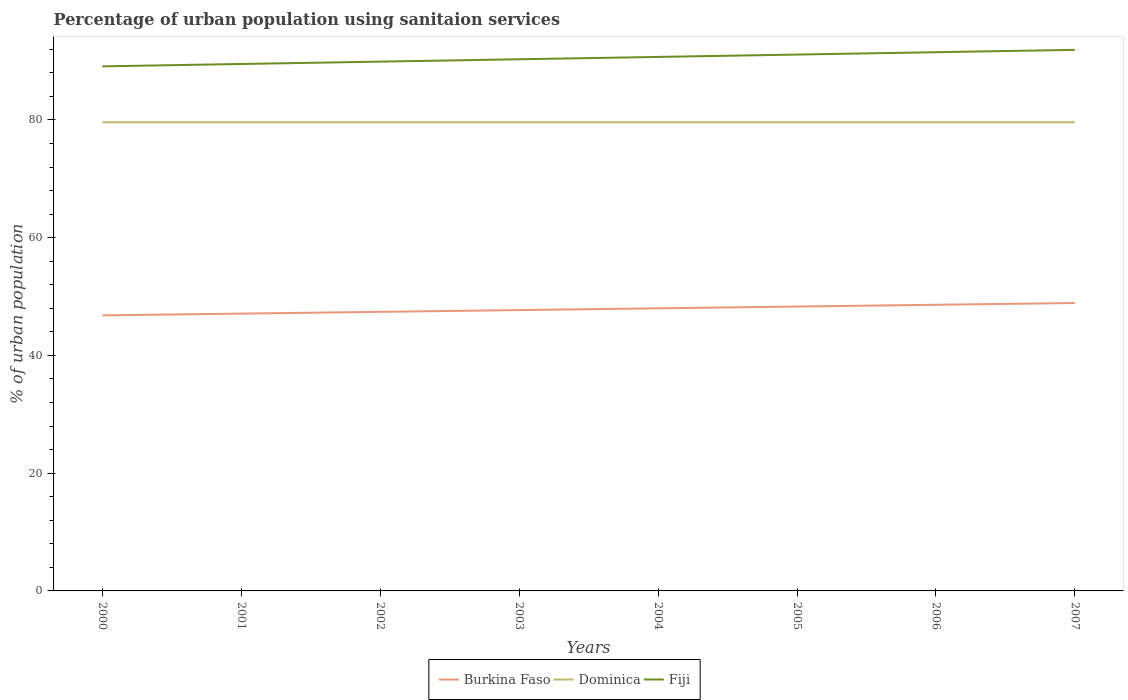Does the line corresponding to Dominica intersect with the line corresponding to Burkina Faso?
Your answer should be compact. No. Across all years, what is the maximum percentage of urban population using sanitaion services in Fiji?
Your response must be concise. 89.1. What is the difference between the highest and the lowest percentage of urban population using sanitaion services in Burkina Faso?
Make the answer very short. 4. How many lines are there?
Offer a terse response. 3. What is the difference between two consecutive major ticks on the Y-axis?
Provide a succinct answer. 20. Are the values on the major ticks of Y-axis written in scientific E-notation?
Your answer should be very brief. No. Where does the legend appear in the graph?
Your response must be concise. Bottom center. How many legend labels are there?
Your response must be concise. 3. How are the legend labels stacked?
Offer a terse response. Horizontal. What is the title of the graph?
Provide a short and direct response. Percentage of urban population using sanitaion services. Does "Andorra" appear as one of the legend labels in the graph?
Give a very brief answer. No. What is the label or title of the Y-axis?
Offer a very short reply. % of urban population. What is the % of urban population in Burkina Faso in 2000?
Make the answer very short. 46.8. What is the % of urban population in Dominica in 2000?
Offer a terse response. 79.6. What is the % of urban population in Fiji in 2000?
Offer a terse response. 89.1. What is the % of urban population of Burkina Faso in 2001?
Offer a terse response. 47.1. What is the % of urban population in Dominica in 2001?
Offer a very short reply. 79.6. What is the % of urban population in Fiji in 2001?
Give a very brief answer. 89.5. What is the % of urban population in Burkina Faso in 2002?
Keep it short and to the point. 47.4. What is the % of urban population in Dominica in 2002?
Offer a terse response. 79.6. What is the % of urban population in Fiji in 2002?
Ensure brevity in your answer.  89.9. What is the % of urban population of Burkina Faso in 2003?
Your answer should be compact. 47.7. What is the % of urban population of Dominica in 2003?
Give a very brief answer. 79.6. What is the % of urban population in Fiji in 2003?
Make the answer very short. 90.3. What is the % of urban population in Burkina Faso in 2004?
Provide a short and direct response. 48. What is the % of urban population in Dominica in 2004?
Give a very brief answer. 79.6. What is the % of urban population of Fiji in 2004?
Your answer should be very brief. 90.7. What is the % of urban population in Burkina Faso in 2005?
Ensure brevity in your answer.  48.3. What is the % of urban population in Dominica in 2005?
Your answer should be very brief. 79.6. What is the % of urban population of Fiji in 2005?
Your answer should be very brief. 91.1. What is the % of urban population of Burkina Faso in 2006?
Ensure brevity in your answer.  48.6. What is the % of urban population of Dominica in 2006?
Keep it short and to the point. 79.6. What is the % of urban population in Fiji in 2006?
Offer a terse response. 91.5. What is the % of urban population of Burkina Faso in 2007?
Provide a short and direct response. 48.9. What is the % of urban population in Dominica in 2007?
Offer a terse response. 79.6. What is the % of urban population in Fiji in 2007?
Give a very brief answer. 91.9. Across all years, what is the maximum % of urban population of Burkina Faso?
Offer a terse response. 48.9. Across all years, what is the maximum % of urban population in Dominica?
Ensure brevity in your answer.  79.6. Across all years, what is the maximum % of urban population of Fiji?
Your response must be concise. 91.9. Across all years, what is the minimum % of urban population in Burkina Faso?
Offer a terse response. 46.8. Across all years, what is the minimum % of urban population of Dominica?
Give a very brief answer. 79.6. Across all years, what is the minimum % of urban population in Fiji?
Your response must be concise. 89.1. What is the total % of urban population of Burkina Faso in the graph?
Give a very brief answer. 382.8. What is the total % of urban population of Dominica in the graph?
Ensure brevity in your answer.  636.8. What is the total % of urban population of Fiji in the graph?
Keep it short and to the point. 724. What is the difference between the % of urban population of Dominica in 2000 and that in 2002?
Provide a short and direct response. 0. What is the difference between the % of urban population in Fiji in 2000 and that in 2002?
Your answer should be compact. -0.8. What is the difference between the % of urban population in Fiji in 2000 and that in 2003?
Provide a succinct answer. -1.2. What is the difference between the % of urban population in Burkina Faso in 2000 and that in 2004?
Your answer should be very brief. -1.2. What is the difference between the % of urban population of Dominica in 2000 and that in 2004?
Make the answer very short. 0. What is the difference between the % of urban population of Fiji in 2000 and that in 2004?
Provide a succinct answer. -1.6. What is the difference between the % of urban population of Burkina Faso in 2000 and that in 2005?
Provide a succinct answer. -1.5. What is the difference between the % of urban population of Dominica in 2000 and that in 2005?
Keep it short and to the point. 0. What is the difference between the % of urban population of Fiji in 2000 and that in 2005?
Your response must be concise. -2. What is the difference between the % of urban population of Burkina Faso in 2000 and that in 2006?
Offer a terse response. -1.8. What is the difference between the % of urban population of Fiji in 2000 and that in 2007?
Make the answer very short. -2.8. What is the difference between the % of urban population in Dominica in 2001 and that in 2002?
Your response must be concise. 0. What is the difference between the % of urban population of Burkina Faso in 2001 and that in 2004?
Make the answer very short. -0.9. What is the difference between the % of urban population in Dominica in 2001 and that in 2004?
Give a very brief answer. 0. What is the difference between the % of urban population in Fiji in 2001 and that in 2004?
Give a very brief answer. -1.2. What is the difference between the % of urban population of Dominica in 2001 and that in 2005?
Offer a terse response. 0. What is the difference between the % of urban population of Burkina Faso in 2001 and that in 2006?
Offer a very short reply. -1.5. What is the difference between the % of urban population of Dominica in 2001 and that in 2006?
Your response must be concise. 0. What is the difference between the % of urban population of Burkina Faso in 2001 and that in 2007?
Provide a short and direct response. -1.8. What is the difference between the % of urban population in Burkina Faso in 2002 and that in 2003?
Offer a terse response. -0.3. What is the difference between the % of urban population of Dominica in 2002 and that in 2003?
Keep it short and to the point. 0. What is the difference between the % of urban population of Burkina Faso in 2002 and that in 2004?
Offer a terse response. -0.6. What is the difference between the % of urban population in Dominica in 2002 and that in 2005?
Give a very brief answer. 0. What is the difference between the % of urban population in Fiji in 2002 and that in 2005?
Your answer should be very brief. -1.2. What is the difference between the % of urban population of Fiji in 2002 and that in 2006?
Give a very brief answer. -1.6. What is the difference between the % of urban population in Dominica in 2002 and that in 2007?
Your response must be concise. 0. What is the difference between the % of urban population in Fiji in 2002 and that in 2007?
Offer a very short reply. -2. What is the difference between the % of urban population of Burkina Faso in 2003 and that in 2004?
Ensure brevity in your answer.  -0.3. What is the difference between the % of urban population of Burkina Faso in 2003 and that in 2005?
Give a very brief answer. -0.6. What is the difference between the % of urban population in Dominica in 2003 and that in 2005?
Keep it short and to the point. 0. What is the difference between the % of urban population in Fiji in 2003 and that in 2005?
Offer a terse response. -0.8. What is the difference between the % of urban population of Fiji in 2003 and that in 2006?
Your response must be concise. -1.2. What is the difference between the % of urban population of Burkina Faso in 2003 and that in 2007?
Offer a terse response. -1.2. What is the difference between the % of urban population of Fiji in 2003 and that in 2007?
Your response must be concise. -1.6. What is the difference between the % of urban population of Dominica in 2004 and that in 2005?
Keep it short and to the point. 0. What is the difference between the % of urban population in Dominica in 2004 and that in 2006?
Keep it short and to the point. 0. What is the difference between the % of urban population in Fiji in 2004 and that in 2006?
Make the answer very short. -0.8. What is the difference between the % of urban population in Burkina Faso in 2004 and that in 2007?
Provide a short and direct response. -0.9. What is the difference between the % of urban population of Dominica in 2004 and that in 2007?
Ensure brevity in your answer.  0. What is the difference between the % of urban population in Fiji in 2004 and that in 2007?
Offer a terse response. -1.2. What is the difference between the % of urban population in Dominica in 2005 and that in 2007?
Give a very brief answer. 0. What is the difference between the % of urban population in Burkina Faso in 2006 and that in 2007?
Your answer should be very brief. -0.3. What is the difference between the % of urban population in Dominica in 2006 and that in 2007?
Your answer should be compact. 0. What is the difference between the % of urban population of Burkina Faso in 2000 and the % of urban population of Dominica in 2001?
Keep it short and to the point. -32.8. What is the difference between the % of urban population of Burkina Faso in 2000 and the % of urban population of Fiji in 2001?
Your response must be concise. -42.7. What is the difference between the % of urban population of Burkina Faso in 2000 and the % of urban population of Dominica in 2002?
Provide a short and direct response. -32.8. What is the difference between the % of urban population in Burkina Faso in 2000 and the % of urban population in Fiji in 2002?
Your answer should be compact. -43.1. What is the difference between the % of urban population of Dominica in 2000 and the % of urban population of Fiji in 2002?
Offer a terse response. -10.3. What is the difference between the % of urban population in Burkina Faso in 2000 and the % of urban population in Dominica in 2003?
Make the answer very short. -32.8. What is the difference between the % of urban population in Burkina Faso in 2000 and the % of urban population in Fiji in 2003?
Your answer should be compact. -43.5. What is the difference between the % of urban population of Burkina Faso in 2000 and the % of urban population of Dominica in 2004?
Offer a terse response. -32.8. What is the difference between the % of urban population of Burkina Faso in 2000 and the % of urban population of Fiji in 2004?
Your response must be concise. -43.9. What is the difference between the % of urban population in Dominica in 2000 and the % of urban population in Fiji in 2004?
Provide a short and direct response. -11.1. What is the difference between the % of urban population in Burkina Faso in 2000 and the % of urban population in Dominica in 2005?
Make the answer very short. -32.8. What is the difference between the % of urban population of Burkina Faso in 2000 and the % of urban population of Fiji in 2005?
Your answer should be compact. -44.3. What is the difference between the % of urban population in Burkina Faso in 2000 and the % of urban population in Dominica in 2006?
Give a very brief answer. -32.8. What is the difference between the % of urban population in Burkina Faso in 2000 and the % of urban population in Fiji in 2006?
Keep it short and to the point. -44.7. What is the difference between the % of urban population of Burkina Faso in 2000 and the % of urban population of Dominica in 2007?
Make the answer very short. -32.8. What is the difference between the % of urban population of Burkina Faso in 2000 and the % of urban population of Fiji in 2007?
Your response must be concise. -45.1. What is the difference between the % of urban population in Burkina Faso in 2001 and the % of urban population in Dominica in 2002?
Your answer should be compact. -32.5. What is the difference between the % of urban population of Burkina Faso in 2001 and the % of urban population of Fiji in 2002?
Your answer should be very brief. -42.8. What is the difference between the % of urban population in Dominica in 2001 and the % of urban population in Fiji in 2002?
Your response must be concise. -10.3. What is the difference between the % of urban population in Burkina Faso in 2001 and the % of urban population in Dominica in 2003?
Keep it short and to the point. -32.5. What is the difference between the % of urban population of Burkina Faso in 2001 and the % of urban population of Fiji in 2003?
Your response must be concise. -43.2. What is the difference between the % of urban population of Dominica in 2001 and the % of urban population of Fiji in 2003?
Provide a short and direct response. -10.7. What is the difference between the % of urban population of Burkina Faso in 2001 and the % of urban population of Dominica in 2004?
Your answer should be compact. -32.5. What is the difference between the % of urban population in Burkina Faso in 2001 and the % of urban population in Fiji in 2004?
Provide a succinct answer. -43.6. What is the difference between the % of urban population in Dominica in 2001 and the % of urban population in Fiji in 2004?
Your answer should be compact. -11.1. What is the difference between the % of urban population in Burkina Faso in 2001 and the % of urban population in Dominica in 2005?
Your response must be concise. -32.5. What is the difference between the % of urban population of Burkina Faso in 2001 and the % of urban population of Fiji in 2005?
Offer a very short reply. -44. What is the difference between the % of urban population of Dominica in 2001 and the % of urban population of Fiji in 2005?
Your answer should be compact. -11.5. What is the difference between the % of urban population in Burkina Faso in 2001 and the % of urban population in Dominica in 2006?
Provide a short and direct response. -32.5. What is the difference between the % of urban population of Burkina Faso in 2001 and the % of urban population of Fiji in 2006?
Ensure brevity in your answer.  -44.4. What is the difference between the % of urban population in Burkina Faso in 2001 and the % of urban population in Dominica in 2007?
Your answer should be compact. -32.5. What is the difference between the % of urban population of Burkina Faso in 2001 and the % of urban population of Fiji in 2007?
Ensure brevity in your answer.  -44.8. What is the difference between the % of urban population in Dominica in 2001 and the % of urban population in Fiji in 2007?
Your response must be concise. -12.3. What is the difference between the % of urban population in Burkina Faso in 2002 and the % of urban population in Dominica in 2003?
Offer a terse response. -32.2. What is the difference between the % of urban population of Burkina Faso in 2002 and the % of urban population of Fiji in 2003?
Your answer should be very brief. -42.9. What is the difference between the % of urban population in Dominica in 2002 and the % of urban population in Fiji in 2003?
Provide a short and direct response. -10.7. What is the difference between the % of urban population of Burkina Faso in 2002 and the % of urban population of Dominica in 2004?
Your response must be concise. -32.2. What is the difference between the % of urban population of Burkina Faso in 2002 and the % of urban population of Fiji in 2004?
Offer a very short reply. -43.3. What is the difference between the % of urban population in Dominica in 2002 and the % of urban population in Fiji in 2004?
Provide a short and direct response. -11.1. What is the difference between the % of urban population in Burkina Faso in 2002 and the % of urban population in Dominica in 2005?
Your response must be concise. -32.2. What is the difference between the % of urban population in Burkina Faso in 2002 and the % of urban population in Fiji in 2005?
Make the answer very short. -43.7. What is the difference between the % of urban population of Dominica in 2002 and the % of urban population of Fiji in 2005?
Your answer should be compact. -11.5. What is the difference between the % of urban population of Burkina Faso in 2002 and the % of urban population of Dominica in 2006?
Your answer should be compact. -32.2. What is the difference between the % of urban population of Burkina Faso in 2002 and the % of urban population of Fiji in 2006?
Ensure brevity in your answer.  -44.1. What is the difference between the % of urban population of Dominica in 2002 and the % of urban population of Fiji in 2006?
Offer a terse response. -11.9. What is the difference between the % of urban population of Burkina Faso in 2002 and the % of urban population of Dominica in 2007?
Your response must be concise. -32.2. What is the difference between the % of urban population of Burkina Faso in 2002 and the % of urban population of Fiji in 2007?
Your answer should be very brief. -44.5. What is the difference between the % of urban population of Dominica in 2002 and the % of urban population of Fiji in 2007?
Give a very brief answer. -12.3. What is the difference between the % of urban population in Burkina Faso in 2003 and the % of urban population in Dominica in 2004?
Your answer should be compact. -31.9. What is the difference between the % of urban population of Burkina Faso in 2003 and the % of urban population of Fiji in 2004?
Provide a succinct answer. -43. What is the difference between the % of urban population in Burkina Faso in 2003 and the % of urban population in Dominica in 2005?
Provide a succinct answer. -31.9. What is the difference between the % of urban population of Burkina Faso in 2003 and the % of urban population of Fiji in 2005?
Offer a terse response. -43.4. What is the difference between the % of urban population of Dominica in 2003 and the % of urban population of Fiji in 2005?
Provide a short and direct response. -11.5. What is the difference between the % of urban population in Burkina Faso in 2003 and the % of urban population in Dominica in 2006?
Your answer should be very brief. -31.9. What is the difference between the % of urban population in Burkina Faso in 2003 and the % of urban population in Fiji in 2006?
Keep it short and to the point. -43.8. What is the difference between the % of urban population in Dominica in 2003 and the % of urban population in Fiji in 2006?
Your response must be concise. -11.9. What is the difference between the % of urban population of Burkina Faso in 2003 and the % of urban population of Dominica in 2007?
Provide a succinct answer. -31.9. What is the difference between the % of urban population in Burkina Faso in 2003 and the % of urban population in Fiji in 2007?
Make the answer very short. -44.2. What is the difference between the % of urban population of Burkina Faso in 2004 and the % of urban population of Dominica in 2005?
Your answer should be very brief. -31.6. What is the difference between the % of urban population in Burkina Faso in 2004 and the % of urban population in Fiji in 2005?
Ensure brevity in your answer.  -43.1. What is the difference between the % of urban population of Dominica in 2004 and the % of urban population of Fiji in 2005?
Your answer should be very brief. -11.5. What is the difference between the % of urban population in Burkina Faso in 2004 and the % of urban population in Dominica in 2006?
Offer a very short reply. -31.6. What is the difference between the % of urban population in Burkina Faso in 2004 and the % of urban population in Fiji in 2006?
Your answer should be compact. -43.5. What is the difference between the % of urban population in Dominica in 2004 and the % of urban population in Fiji in 2006?
Offer a very short reply. -11.9. What is the difference between the % of urban population in Burkina Faso in 2004 and the % of urban population in Dominica in 2007?
Give a very brief answer. -31.6. What is the difference between the % of urban population in Burkina Faso in 2004 and the % of urban population in Fiji in 2007?
Keep it short and to the point. -43.9. What is the difference between the % of urban population in Dominica in 2004 and the % of urban population in Fiji in 2007?
Give a very brief answer. -12.3. What is the difference between the % of urban population of Burkina Faso in 2005 and the % of urban population of Dominica in 2006?
Keep it short and to the point. -31.3. What is the difference between the % of urban population in Burkina Faso in 2005 and the % of urban population in Fiji in 2006?
Ensure brevity in your answer.  -43.2. What is the difference between the % of urban population of Burkina Faso in 2005 and the % of urban population of Dominica in 2007?
Offer a terse response. -31.3. What is the difference between the % of urban population of Burkina Faso in 2005 and the % of urban population of Fiji in 2007?
Keep it short and to the point. -43.6. What is the difference between the % of urban population in Dominica in 2005 and the % of urban population in Fiji in 2007?
Your response must be concise. -12.3. What is the difference between the % of urban population in Burkina Faso in 2006 and the % of urban population in Dominica in 2007?
Ensure brevity in your answer.  -31. What is the difference between the % of urban population in Burkina Faso in 2006 and the % of urban population in Fiji in 2007?
Provide a short and direct response. -43.3. What is the average % of urban population of Burkina Faso per year?
Keep it short and to the point. 47.85. What is the average % of urban population of Dominica per year?
Your answer should be compact. 79.6. What is the average % of urban population in Fiji per year?
Your answer should be compact. 90.5. In the year 2000, what is the difference between the % of urban population of Burkina Faso and % of urban population of Dominica?
Your answer should be compact. -32.8. In the year 2000, what is the difference between the % of urban population of Burkina Faso and % of urban population of Fiji?
Your answer should be very brief. -42.3. In the year 2000, what is the difference between the % of urban population of Dominica and % of urban population of Fiji?
Ensure brevity in your answer.  -9.5. In the year 2001, what is the difference between the % of urban population in Burkina Faso and % of urban population in Dominica?
Give a very brief answer. -32.5. In the year 2001, what is the difference between the % of urban population of Burkina Faso and % of urban population of Fiji?
Provide a short and direct response. -42.4. In the year 2002, what is the difference between the % of urban population of Burkina Faso and % of urban population of Dominica?
Your answer should be compact. -32.2. In the year 2002, what is the difference between the % of urban population in Burkina Faso and % of urban population in Fiji?
Offer a terse response. -42.5. In the year 2003, what is the difference between the % of urban population of Burkina Faso and % of urban population of Dominica?
Ensure brevity in your answer.  -31.9. In the year 2003, what is the difference between the % of urban population of Burkina Faso and % of urban population of Fiji?
Provide a succinct answer. -42.6. In the year 2003, what is the difference between the % of urban population of Dominica and % of urban population of Fiji?
Provide a succinct answer. -10.7. In the year 2004, what is the difference between the % of urban population in Burkina Faso and % of urban population in Dominica?
Make the answer very short. -31.6. In the year 2004, what is the difference between the % of urban population in Burkina Faso and % of urban population in Fiji?
Make the answer very short. -42.7. In the year 2005, what is the difference between the % of urban population in Burkina Faso and % of urban population in Dominica?
Your response must be concise. -31.3. In the year 2005, what is the difference between the % of urban population in Burkina Faso and % of urban population in Fiji?
Provide a short and direct response. -42.8. In the year 2005, what is the difference between the % of urban population of Dominica and % of urban population of Fiji?
Provide a succinct answer. -11.5. In the year 2006, what is the difference between the % of urban population of Burkina Faso and % of urban population of Dominica?
Ensure brevity in your answer.  -31. In the year 2006, what is the difference between the % of urban population of Burkina Faso and % of urban population of Fiji?
Provide a succinct answer. -42.9. In the year 2007, what is the difference between the % of urban population in Burkina Faso and % of urban population in Dominica?
Your answer should be very brief. -30.7. In the year 2007, what is the difference between the % of urban population of Burkina Faso and % of urban population of Fiji?
Ensure brevity in your answer.  -43. What is the ratio of the % of urban population of Dominica in 2000 to that in 2001?
Provide a short and direct response. 1. What is the ratio of the % of urban population of Fiji in 2000 to that in 2001?
Offer a very short reply. 1. What is the ratio of the % of urban population of Burkina Faso in 2000 to that in 2002?
Offer a very short reply. 0.99. What is the ratio of the % of urban population in Burkina Faso in 2000 to that in 2003?
Make the answer very short. 0.98. What is the ratio of the % of urban population in Dominica in 2000 to that in 2003?
Your response must be concise. 1. What is the ratio of the % of urban population of Fiji in 2000 to that in 2003?
Your answer should be very brief. 0.99. What is the ratio of the % of urban population in Dominica in 2000 to that in 2004?
Provide a short and direct response. 1. What is the ratio of the % of urban population of Fiji in 2000 to that in 2004?
Provide a succinct answer. 0.98. What is the ratio of the % of urban population in Burkina Faso in 2000 to that in 2005?
Your response must be concise. 0.97. What is the ratio of the % of urban population of Dominica in 2000 to that in 2005?
Your response must be concise. 1. What is the ratio of the % of urban population of Fiji in 2000 to that in 2005?
Give a very brief answer. 0.98. What is the ratio of the % of urban population of Dominica in 2000 to that in 2006?
Your answer should be very brief. 1. What is the ratio of the % of urban population of Fiji in 2000 to that in 2006?
Provide a succinct answer. 0.97. What is the ratio of the % of urban population of Burkina Faso in 2000 to that in 2007?
Give a very brief answer. 0.96. What is the ratio of the % of urban population of Fiji in 2000 to that in 2007?
Your response must be concise. 0.97. What is the ratio of the % of urban population of Burkina Faso in 2001 to that in 2002?
Provide a short and direct response. 0.99. What is the ratio of the % of urban population in Dominica in 2001 to that in 2002?
Ensure brevity in your answer.  1. What is the ratio of the % of urban population of Burkina Faso in 2001 to that in 2003?
Provide a short and direct response. 0.99. What is the ratio of the % of urban population of Dominica in 2001 to that in 2003?
Keep it short and to the point. 1. What is the ratio of the % of urban population in Burkina Faso in 2001 to that in 2004?
Keep it short and to the point. 0.98. What is the ratio of the % of urban population in Fiji in 2001 to that in 2004?
Ensure brevity in your answer.  0.99. What is the ratio of the % of urban population of Burkina Faso in 2001 to that in 2005?
Provide a short and direct response. 0.98. What is the ratio of the % of urban population of Dominica in 2001 to that in 2005?
Offer a terse response. 1. What is the ratio of the % of urban population in Fiji in 2001 to that in 2005?
Provide a short and direct response. 0.98. What is the ratio of the % of urban population in Burkina Faso in 2001 to that in 2006?
Offer a very short reply. 0.97. What is the ratio of the % of urban population in Dominica in 2001 to that in 2006?
Your response must be concise. 1. What is the ratio of the % of urban population in Fiji in 2001 to that in 2006?
Offer a terse response. 0.98. What is the ratio of the % of urban population of Burkina Faso in 2001 to that in 2007?
Your answer should be compact. 0.96. What is the ratio of the % of urban population of Dominica in 2001 to that in 2007?
Give a very brief answer. 1. What is the ratio of the % of urban population in Fiji in 2001 to that in 2007?
Keep it short and to the point. 0.97. What is the ratio of the % of urban population in Burkina Faso in 2002 to that in 2003?
Make the answer very short. 0.99. What is the ratio of the % of urban population of Dominica in 2002 to that in 2003?
Provide a succinct answer. 1. What is the ratio of the % of urban population of Burkina Faso in 2002 to that in 2004?
Offer a very short reply. 0.99. What is the ratio of the % of urban population in Dominica in 2002 to that in 2004?
Keep it short and to the point. 1. What is the ratio of the % of urban population of Fiji in 2002 to that in 2004?
Give a very brief answer. 0.99. What is the ratio of the % of urban population of Burkina Faso in 2002 to that in 2005?
Keep it short and to the point. 0.98. What is the ratio of the % of urban population of Dominica in 2002 to that in 2005?
Give a very brief answer. 1. What is the ratio of the % of urban population in Burkina Faso in 2002 to that in 2006?
Offer a terse response. 0.98. What is the ratio of the % of urban population of Dominica in 2002 to that in 2006?
Ensure brevity in your answer.  1. What is the ratio of the % of urban population of Fiji in 2002 to that in 2006?
Provide a succinct answer. 0.98. What is the ratio of the % of urban population in Burkina Faso in 2002 to that in 2007?
Your response must be concise. 0.97. What is the ratio of the % of urban population in Fiji in 2002 to that in 2007?
Keep it short and to the point. 0.98. What is the ratio of the % of urban population of Burkina Faso in 2003 to that in 2005?
Make the answer very short. 0.99. What is the ratio of the % of urban population in Dominica in 2003 to that in 2005?
Keep it short and to the point. 1. What is the ratio of the % of urban population in Burkina Faso in 2003 to that in 2006?
Keep it short and to the point. 0.98. What is the ratio of the % of urban population in Dominica in 2003 to that in 2006?
Give a very brief answer. 1. What is the ratio of the % of urban population of Fiji in 2003 to that in 2006?
Offer a terse response. 0.99. What is the ratio of the % of urban population in Burkina Faso in 2003 to that in 2007?
Your response must be concise. 0.98. What is the ratio of the % of urban population of Dominica in 2003 to that in 2007?
Provide a succinct answer. 1. What is the ratio of the % of urban population of Fiji in 2003 to that in 2007?
Give a very brief answer. 0.98. What is the ratio of the % of urban population in Dominica in 2004 to that in 2006?
Offer a terse response. 1. What is the ratio of the % of urban population of Burkina Faso in 2004 to that in 2007?
Your response must be concise. 0.98. What is the ratio of the % of urban population in Fiji in 2004 to that in 2007?
Your answer should be compact. 0.99. What is the ratio of the % of urban population in Burkina Faso in 2005 to that in 2006?
Give a very brief answer. 0.99. What is the ratio of the % of urban population in Dominica in 2005 to that in 2006?
Provide a short and direct response. 1. What is the ratio of the % of urban population in Fiji in 2005 to that in 2007?
Make the answer very short. 0.99. What is the ratio of the % of urban population in Dominica in 2006 to that in 2007?
Offer a terse response. 1. What is the difference between the highest and the second highest % of urban population of Burkina Faso?
Your answer should be compact. 0.3. What is the difference between the highest and the second highest % of urban population of Dominica?
Offer a very short reply. 0. What is the difference between the highest and the second highest % of urban population of Fiji?
Your answer should be very brief. 0.4. What is the difference between the highest and the lowest % of urban population of Burkina Faso?
Give a very brief answer. 2.1. 